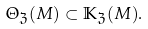<formula> <loc_0><loc_0><loc_500><loc_500>\Theta _ { \mathfrak { Z } } ( M ) \subset \mathbb { K } _ { \mathfrak { Z } } ( M ) .</formula> 